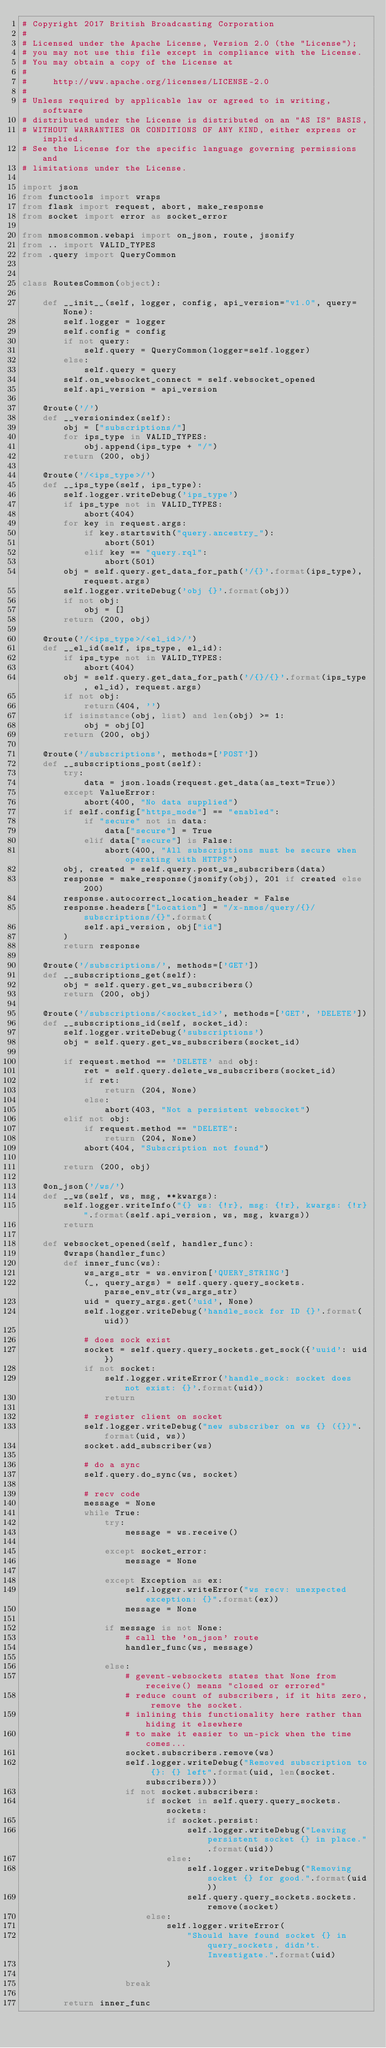Convert code to text. <code><loc_0><loc_0><loc_500><loc_500><_Python_># Copyright 2017 British Broadcasting Corporation
#
# Licensed under the Apache License, Version 2.0 (the "License");
# you may not use this file except in compliance with the License.
# You may obtain a copy of the License at
#
#     http://www.apache.org/licenses/LICENSE-2.0
#
# Unless required by applicable law or agreed to in writing, software
# distributed under the License is distributed on an "AS IS" BASIS,
# WITHOUT WARRANTIES OR CONDITIONS OF ANY KIND, either express or implied.
# See the License for the specific language governing permissions and
# limitations under the License.

import json
from functools import wraps
from flask import request, abort, make_response
from socket import error as socket_error

from nmoscommon.webapi import on_json, route, jsonify
from .. import VALID_TYPES
from .query import QueryCommon


class RoutesCommon(object):

    def __init__(self, logger, config, api_version="v1.0", query=None):
        self.logger = logger
        self.config = config
        if not query:
            self.query = QueryCommon(logger=self.logger)
        else:
            self.query = query
        self.on_websocket_connect = self.websocket_opened
        self.api_version = api_version

    @route('/')
    def __versionindex(self):
        obj = ["subscriptions/"]
        for ips_type in VALID_TYPES:
            obj.append(ips_type + "/")
        return (200, obj)

    @route('/<ips_type>/')
    def __ips_type(self, ips_type):
        self.logger.writeDebug('ips_type')
        if ips_type not in VALID_TYPES:
            abort(404)
        for key in request.args:
            if key.startswith("query.ancestry_"):
                abort(501)
            elif key == "query.rql":
                abort(501)
        obj = self.query.get_data_for_path('/{}'.format(ips_type), request.args)
        self.logger.writeDebug('obj {}'.format(obj))
        if not obj:
            obj = []
        return (200, obj)

    @route('/<ips_type>/<el_id>/')
    def __el_id(self, ips_type, el_id):
        if ips_type not in VALID_TYPES:
            abort(404)
        obj = self.query.get_data_for_path('/{}/{}'.format(ips_type, el_id), request.args)
        if not obj:
            return(404, '')
        if isinstance(obj, list) and len(obj) >= 1:
            obj = obj[0]
        return (200, obj)

    @route('/subscriptions', methods=['POST'])
    def __subscriptions_post(self):
        try:
            data = json.loads(request.get_data(as_text=True))
        except ValueError:
            abort(400, "No data supplied")
        if self.config["https_mode"] == "enabled":
            if "secure" not in data:
                data["secure"] = True
            elif data["secure"] is False:
                abort(400, "All subscriptions must be secure when operating with HTTPS")
        obj, created = self.query.post_ws_subscribers(data)
        response = make_response(jsonify(obj), 201 if created else 200)
        response.autocorrect_location_header = False
        response.headers["Location"] = "/x-nmos/query/{}/subscriptions/{}".format(
            self.api_version, obj["id"]
        )
        return response

    @route('/subscriptions/', methods=['GET'])
    def __subscriptions_get(self):
        obj = self.query.get_ws_subscribers()
        return (200, obj)

    @route('/subscriptions/<socket_id>', methods=['GET', 'DELETE'])
    def __subscriptions_id(self, socket_id):
        self.logger.writeDebug('subscriptions')
        obj = self.query.get_ws_subscribers(socket_id)

        if request.method == 'DELETE' and obj:
            ret = self.query.delete_ws_subscribers(socket_id)
            if ret:
                return (204, None)
            else:
                abort(403, "Not a persistent websocket")
        elif not obj:
            if request.method == "DELETE":
                return (204, None)
            abort(404, "Subscription not found")

        return (200, obj)

    @on_json('/ws/')
    def __ws(self, ws, msg, **kwargs):
        self.logger.writeInfo("{} ws: {!r}, msg: {!r}, kwargs: {!r}".format(self.api_version, ws, msg, kwargs))
        return

    def websocket_opened(self, handler_func):
        @wraps(handler_func)
        def inner_func(ws):
            ws_args_str = ws.environ['QUERY_STRING']
            (_, query_args) = self.query.query_sockets.parse_env_str(ws_args_str)
            uid = query_args.get('uid', None)
            self.logger.writeDebug('handle_sock for ID {}'.format(uid))

            # does sock exist
            socket = self.query.query_sockets.get_sock({'uuid': uid})
            if not socket:
                self.logger.writeError('handle_sock: socket does not exist: {}'.format(uid))
                return

            # register client on socket
            self.logger.writeDebug("new subscriber on ws {} ({})".format(uid, ws))
            socket.add_subscriber(ws)

            # do a sync
            self.query.do_sync(ws, socket)

            # recv code
            message = None
            while True:
                try:
                    message = ws.receive()

                except socket_error:
                    message = None

                except Exception as ex:
                    self.logger.writeError("ws recv: unexpected exception: {}".format(ex))
                    message = None

                if message is not None:
                    # call the 'on_json' route
                    handler_func(ws, message)

                else:
                    # gevent-websockets states that None from receive() means "closed or errored"
                    # reduce count of subscribers, if it hits zero, remove the socket.
                    # inlining this functionality here rather than hiding it elsewhere
                    # to make it easier to un-pick when the time comes...
                    socket.subscribers.remove(ws)
                    self.logger.writeDebug("Removed subscription to {}: {} left".format(uid, len(socket.subscribers)))
                    if not socket.subscribers:
                        if socket in self.query.query_sockets.sockets:
                            if socket.persist:
                                self.logger.writeDebug("Leaving persistent socket {} in place.".format(uid))
                            else:
                                self.logger.writeDebug("Removing socket {} for good.".format(uid))
                                self.query.query_sockets.sockets.remove(socket)
                        else:
                            self.logger.writeError(
                                "Should have found socket {} in query_sockets, didn't. Investigate.".format(uid)
                            )

                    break

        return inner_func
</code> 